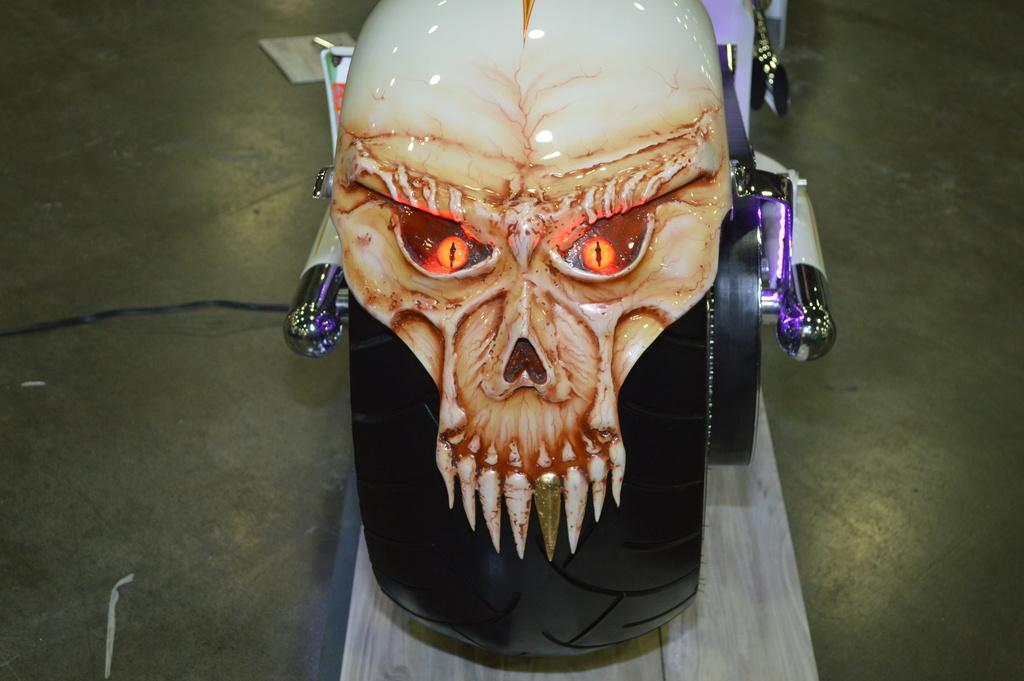What is the main subject of the image? The main subject of the image is a sculpture of a skull. What type of lights are used in the sculpture? The sculpture has digital lights. What type of twist can be seen in the book in the image? There is no book present in the image, so there is no twist to observe. 